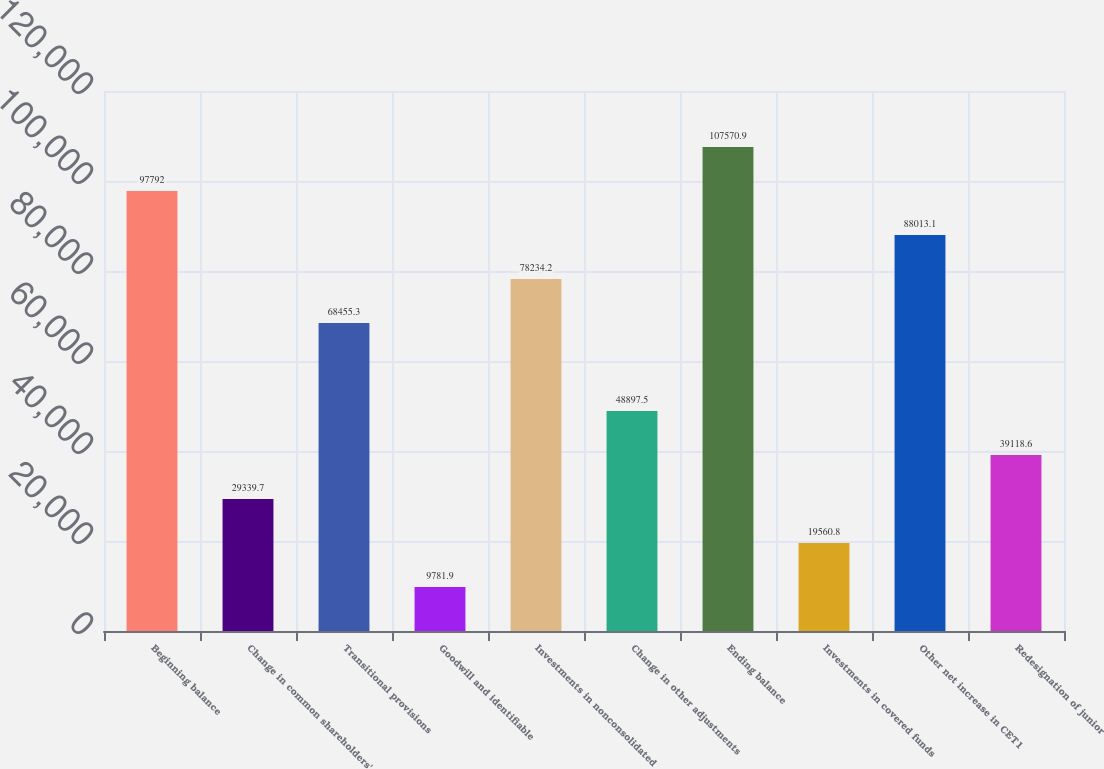Convert chart to OTSL. <chart><loc_0><loc_0><loc_500><loc_500><bar_chart><fcel>Beginning balance<fcel>Change in common shareholders'<fcel>Transitional provisions<fcel>Goodwill and identifiable<fcel>Investments in nonconsolidated<fcel>Change in other adjustments<fcel>Ending balance<fcel>Investments in covered funds<fcel>Other net increase in CET1<fcel>Redesignation of junior<nl><fcel>97792<fcel>29339.7<fcel>68455.3<fcel>9781.9<fcel>78234.2<fcel>48897.5<fcel>107571<fcel>19560.8<fcel>88013.1<fcel>39118.6<nl></chart> 